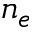Convert formula to latex. <formula><loc_0><loc_0><loc_500><loc_500>n _ { e }</formula> 